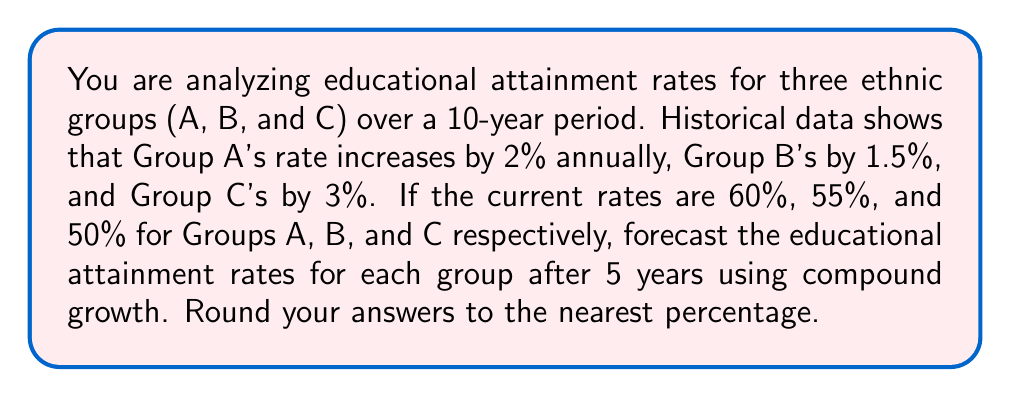Could you help me with this problem? To forecast the educational attainment rates, we'll use the compound growth formula:

$A = P(1 + r)^t$

Where:
$A$ = Final amount
$P$ = Initial principal balance
$r$ = Annual interest rate (in decimal form)
$t$ = Number of years

For Group A:
$P = 60\%$, $r = 2\% = 0.02$, $t = 5$

$A_A = 60\%(1 + 0.02)^5 = 60\% \times 1.1041 = 66.25\%$

Rounded to the nearest percentage: 66%

For Group B:
$P = 55\%$, $r = 1.5\% = 0.015$, $t = 5$

$A_B = 55\%(1 + 0.015)^5 = 55\% \times 1.0773 = 59.25\%$

Rounded to the nearest percentage: 59%

For Group C:
$P = 50\%$, $r = 3\% = 0.03$, $t = 5$

$A_C = 50\%(1 + 0.03)^5 = 50\% \times 1.1593 = 57.97\%$

Rounded to the nearest percentage: 58%
Answer: Group A: 66%, Group B: 59%, Group C: 58% 